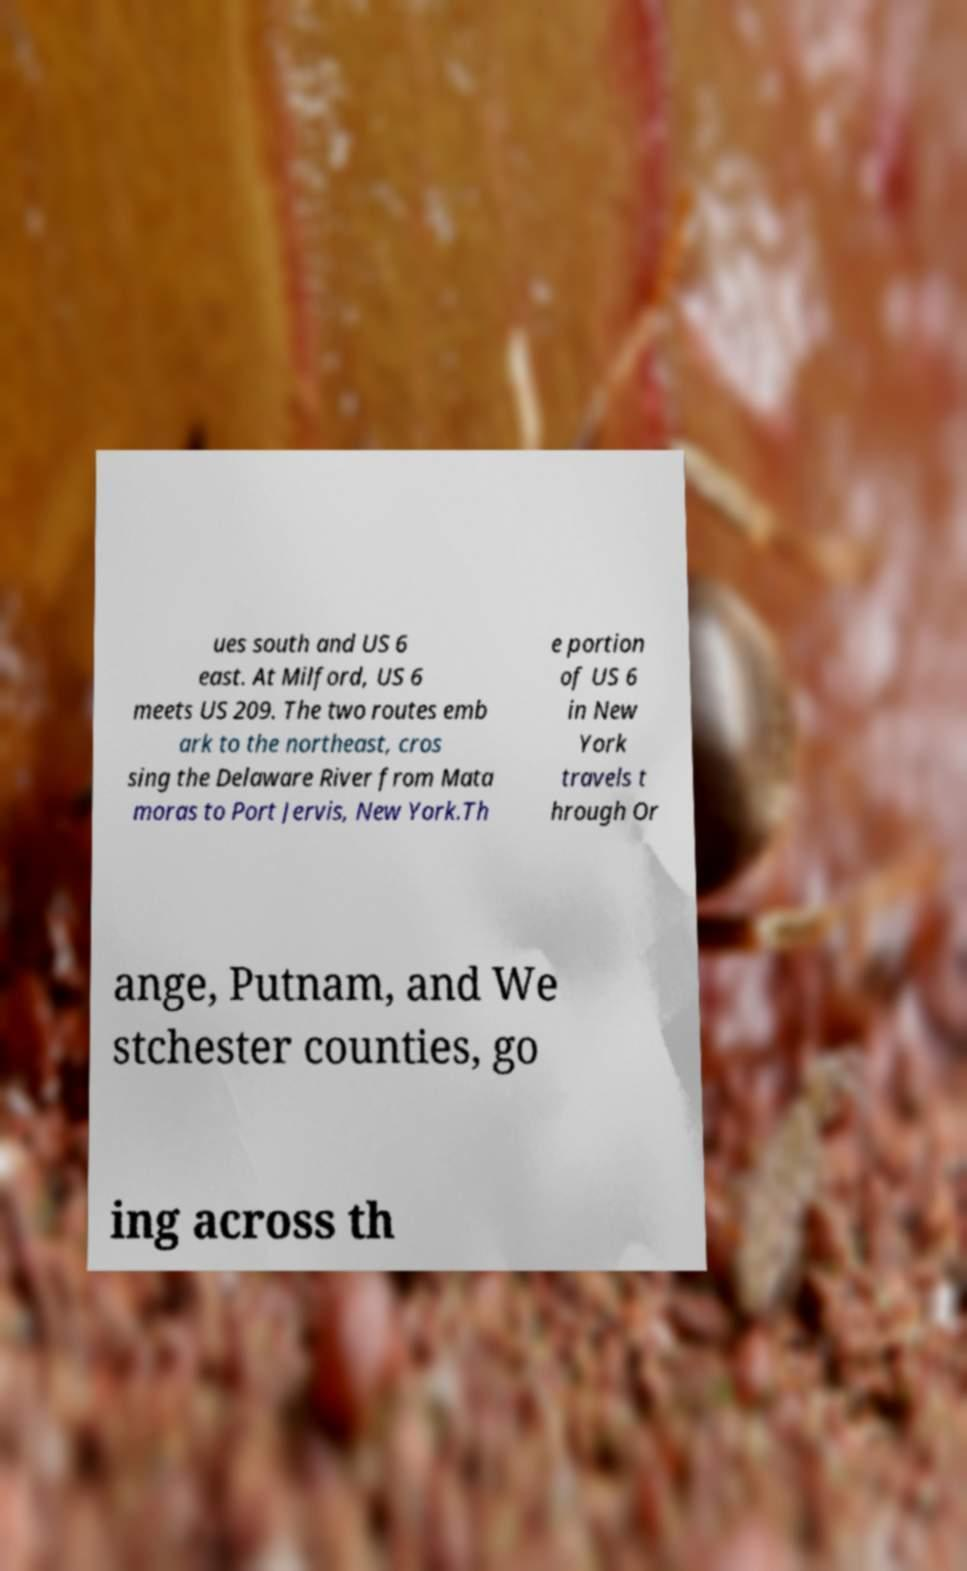For documentation purposes, I need the text within this image transcribed. Could you provide that? ues south and US 6 east. At Milford, US 6 meets US 209. The two routes emb ark to the northeast, cros sing the Delaware River from Mata moras to Port Jervis, New York.Th e portion of US 6 in New York travels t hrough Or ange, Putnam, and We stchester counties, go ing across th 